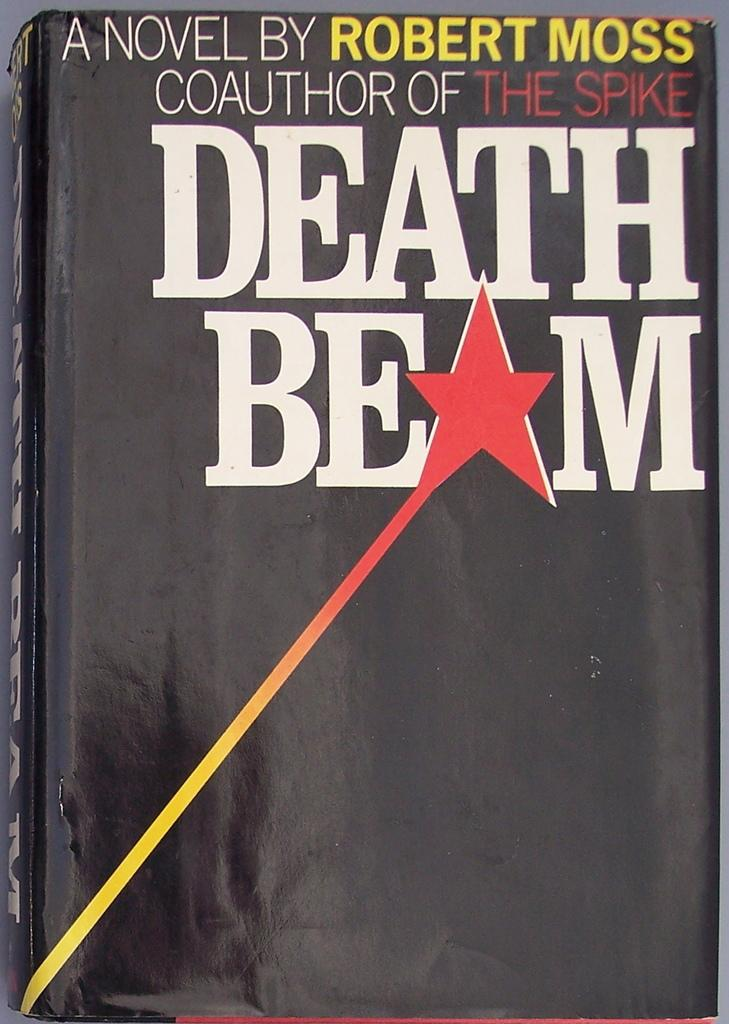<image>
Provide a brief description of the given image. Death Beam chapter book by robert moss who is the coauthor of the spike 